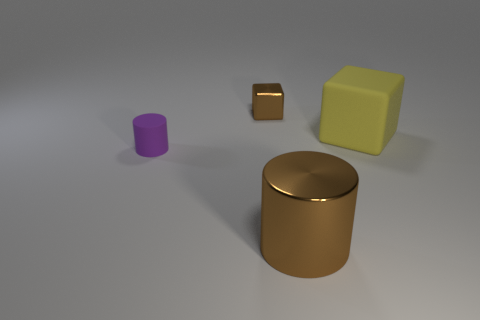What is the material of the cylinder that is the same color as the small block?
Ensure brevity in your answer.  Metal. The shiny thing that is behind the rubber cylinder behind the large brown object that is in front of the tiny matte object is what color?
Provide a succinct answer. Brown. How many rubber things are small gray cylinders or tiny brown cubes?
Keep it short and to the point. 0. Does the brown shiny block have the same size as the metal cylinder?
Your response must be concise. No. Are there fewer large brown shiny things that are behind the big yellow object than matte cylinders in front of the purple cylinder?
Make the answer very short. No. Are there any other things that are the same size as the rubber block?
Keep it short and to the point. Yes. How big is the purple matte cylinder?
Your response must be concise. Small. What number of small objects are either blue matte things or things?
Offer a very short reply. 2. Do the rubber cylinder and the cube on the left side of the yellow cube have the same size?
Ensure brevity in your answer.  Yes. Is there anything else that is the same shape as the yellow object?
Keep it short and to the point. Yes. 